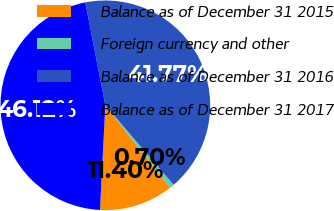<chart> <loc_0><loc_0><loc_500><loc_500><pie_chart><fcel>Balance as of December 31 2015<fcel>Foreign currency and other<fcel>Balance as of December 31 2016<fcel>Balance as of December 31 2017<nl><fcel>11.4%<fcel>0.7%<fcel>41.77%<fcel>46.12%<nl></chart> 